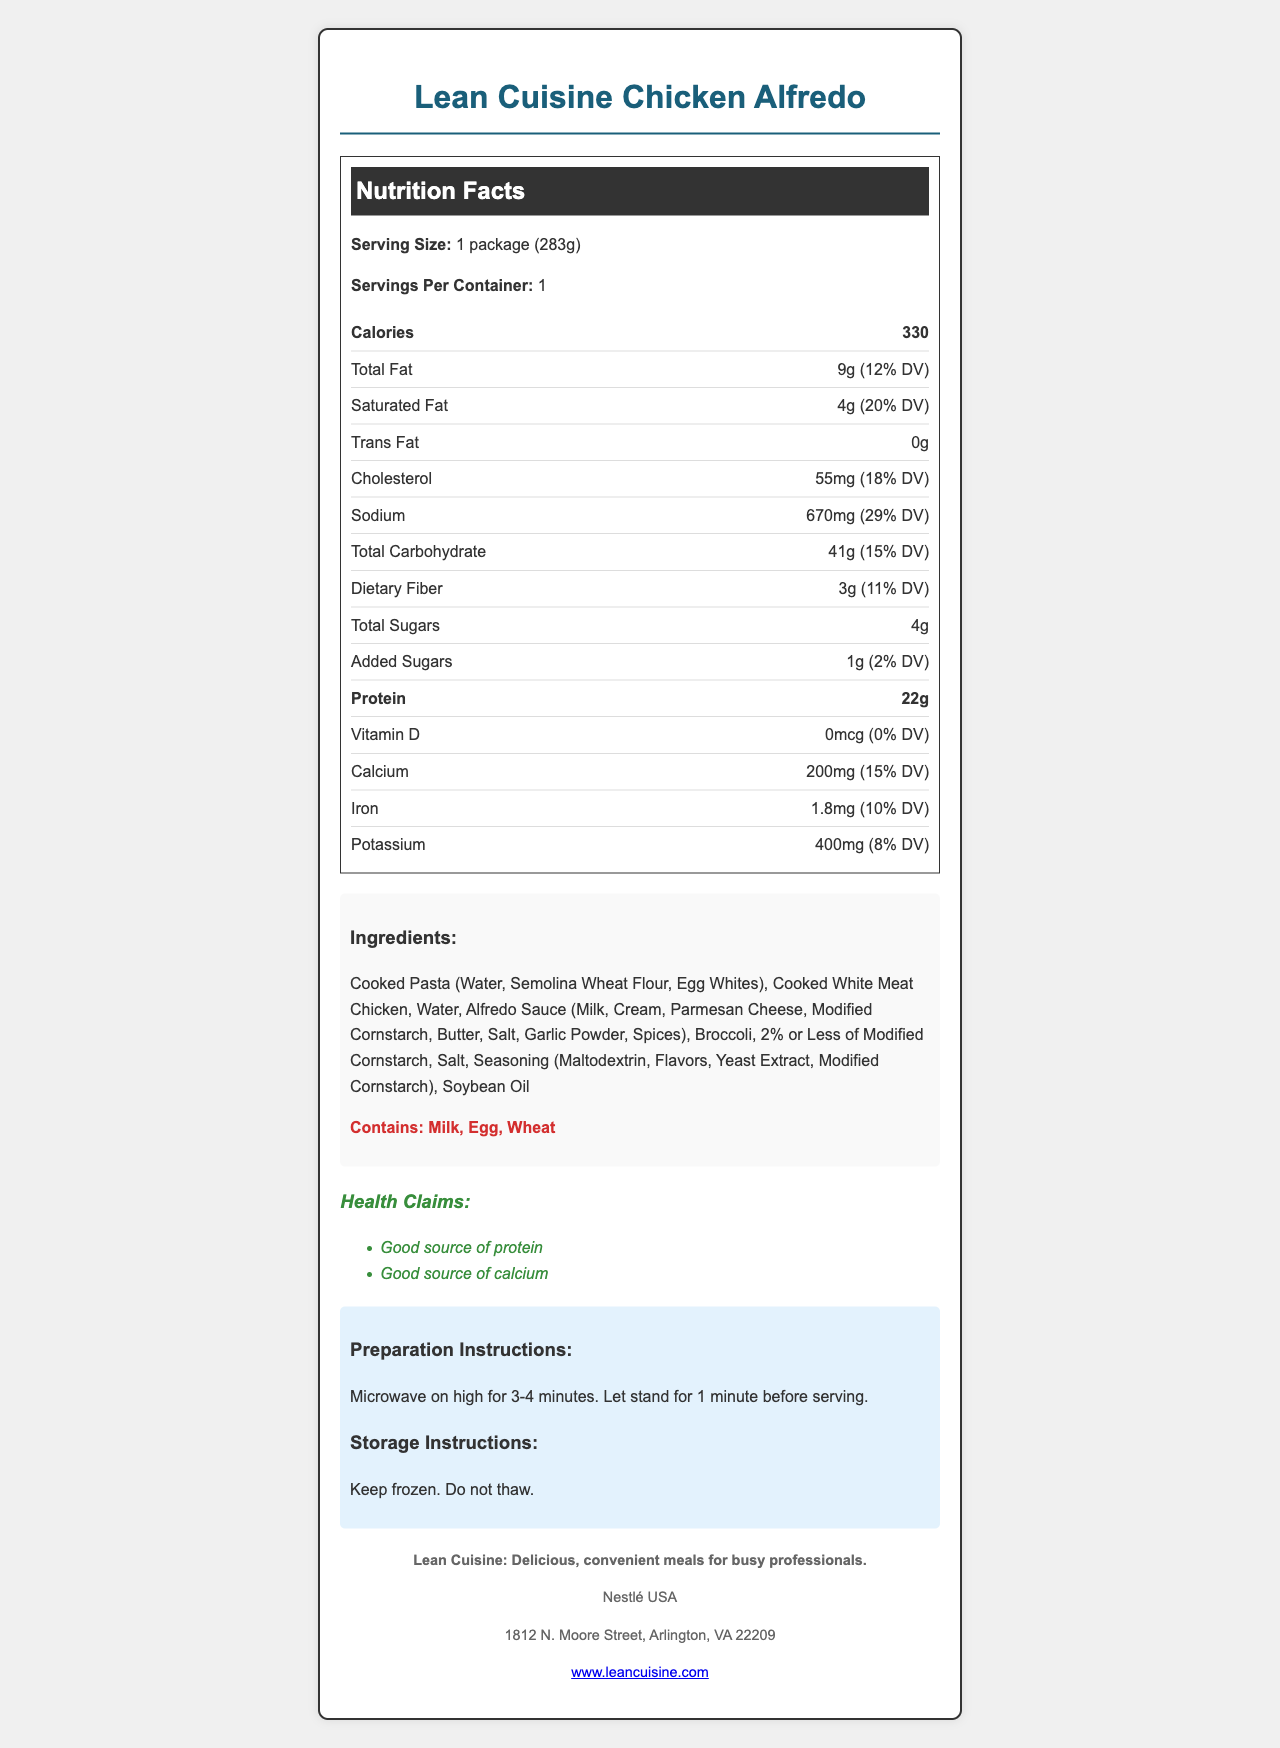what is the serving size? The serving size is clearly stated in the document as "1 package (283g)".
Answer: 1 package (283g) how many calories are in one serving? The document mentions that the total calories per serving are 330.
Answer: 330 what percentage of the daily value is the saturated fat? The saturated fat amount of 4g corresponds to 20% of the daily value.
Answer: 20% is there any trans fat in the product? The document indicates that the amount of trans fat is 0g.
Answer: No name an allergen mentioned in the document? The allergens section lists Milk, Egg, and Wheat.
Answer: Milk what are the main ingredients in alfredo sauce as per the document? The alfredo sauce ingredients are listed as Milk, Cream, Parmesan Cheese, Modified Cornstarch, Butter, Salt, Garlic Powder, and Spices.
Answer: Milk, Cream, Parmesan Cheese, Modified Cornstarch, Butter, Salt, Garlic Powder, Spices what is the total amount of dietary fiber in this product? The total dietary fiber amount is indicated as 3g.
Answer: 3g how should the product be prepared? 
A. Bake in the oven at 350°F for 20 minutes
B. Microwave on high for 3-4 minutes
C. Boil in water for 10 minutes As per the preparation instructions, the product should be microwaved on high for 3-4 minutes.
Answer: B: Microwave on high for 3-4 minutes which nutrient has the highest daily value percentage?
A. Saturated Fat
B. Sodium
C. Cholesterol
D. Carbohydrates Sodium has the highest daily value percentage at 29%, compared to Saturated Fat (20%), Cholesterol (18%), and Carbohydrates (15%).
Answer: B: Sodium does this product contain added sugars? The document lists added sugars as 1g, which corresponds to 2% of the daily value.
Answer: Yes summarize the main idea of the document. The summary of the document covers all aspects of the contents including nutrition facts, ingredients, allergens, health claims, preparation and storage information, and brand details.
Answer: It provides detailed nutrition information for the Lean Cuisine Chicken Alfredo meal, including serving size, calories, nutrient amounts, ingredients, allergens, health claims, preparation and storage instructions, and brand and company information. how many servings are there per container? The document states there is 1 serving per container.
Answer: 1 what is the total amount of sodium in one serving? The document mentions that the sodium content per serving is 670mg.
Answer: 670mg what is the address of Nestlé USA? The company info section provides the address of Nestlé USA.
Answer: 1812 N. Moore Street, Arlington, VA 22209 can I store this product in the fridge? The storage instructions indicate the product should be kept frozen and not thawed.
Answer: No what is the source of protein in this product? The document states it's a good source of protein but does not specify the exact source, which might be inferred to be the chicken or pasta but is not explicitly mentioned.
Answer: Not enough information 